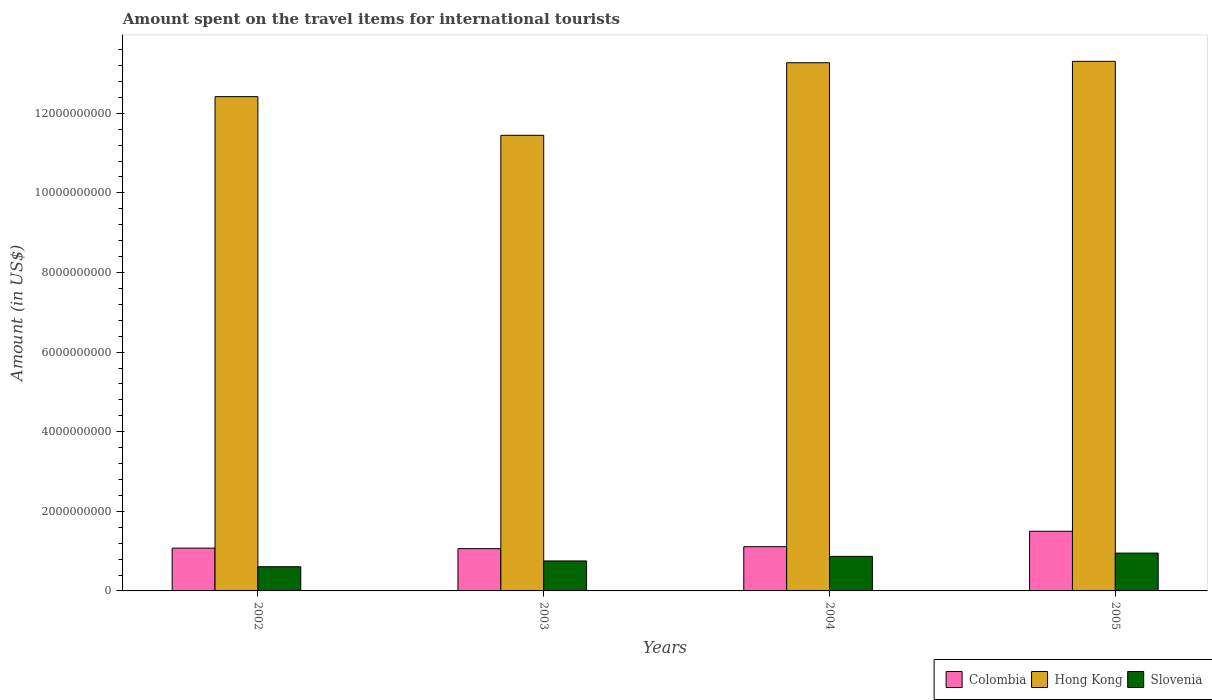How many different coloured bars are there?
Provide a succinct answer. 3. Are the number of bars per tick equal to the number of legend labels?
Provide a succinct answer. Yes. What is the amount spent on the travel items for international tourists in Colombia in 2004?
Offer a very short reply. 1.11e+09. Across all years, what is the maximum amount spent on the travel items for international tourists in Hong Kong?
Offer a terse response. 1.33e+1. Across all years, what is the minimum amount spent on the travel items for international tourists in Hong Kong?
Your answer should be very brief. 1.14e+1. In which year was the amount spent on the travel items for international tourists in Slovenia maximum?
Offer a terse response. 2005. What is the total amount spent on the travel items for international tourists in Colombia in the graph?
Offer a very short reply. 4.75e+09. What is the difference between the amount spent on the travel items for international tourists in Slovenia in 2003 and that in 2005?
Offer a terse response. -1.97e+08. What is the difference between the amount spent on the travel items for international tourists in Hong Kong in 2005 and the amount spent on the travel items for international tourists in Colombia in 2002?
Your answer should be compact. 1.22e+1. What is the average amount spent on the travel items for international tourists in Colombia per year?
Make the answer very short. 1.19e+09. In the year 2005, what is the difference between the amount spent on the travel items for international tourists in Colombia and amount spent on the travel items for international tourists in Hong Kong?
Your answer should be very brief. -1.18e+1. In how many years, is the amount spent on the travel items for international tourists in Hong Kong greater than 10400000000 US$?
Offer a terse response. 4. What is the ratio of the amount spent on the travel items for international tourists in Colombia in 2002 to that in 2003?
Keep it short and to the point. 1.01. Is the amount spent on the travel items for international tourists in Hong Kong in 2002 less than that in 2005?
Keep it short and to the point. Yes. Is the difference between the amount spent on the travel items for international tourists in Colombia in 2003 and 2005 greater than the difference between the amount spent on the travel items for international tourists in Hong Kong in 2003 and 2005?
Give a very brief answer. Yes. What is the difference between the highest and the second highest amount spent on the travel items for international tourists in Colombia?
Your response must be concise. 3.88e+08. What is the difference between the highest and the lowest amount spent on the travel items for international tourists in Colombia?
Give a very brief answer. 4.37e+08. Is the sum of the amount spent on the travel items for international tourists in Colombia in 2003 and 2004 greater than the maximum amount spent on the travel items for international tourists in Slovenia across all years?
Offer a very short reply. Yes. What does the 2nd bar from the left in 2003 represents?
Make the answer very short. Hong Kong. What does the 2nd bar from the right in 2005 represents?
Ensure brevity in your answer.  Hong Kong. Is it the case that in every year, the sum of the amount spent on the travel items for international tourists in Hong Kong and amount spent on the travel items for international tourists in Slovenia is greater than the amount spent on the travel items for international tourists in Colombia?
Keep it short and to the point. Yes. How many years are there in the graph?
Offer a terse response. 4. Are the values on the major ticks of Y-axis written in scientific E-notation?
Your response must be concise. No. Does the graph contain any zero values?
Your answer should be compact. No. Where does the legend appear in the graph?
Offer a terse response. Bottom right. How many legend labels are there?
Offer a very short reply. 3. How are the legend labels stacked?
Your answer should be compact. Horizontal. What is the title of the graph?
Ensure brevity in your answer.  Amount spent on the travel items for international tourists. What is the label or title of the X-axis?
Ensure brevity in your answer.  Years. What is the label or title of the Y-axis?
Offer a terse response. Amount (in US$). What is the Amount (in US$) in Colombia in 2002?
Provide a short and direct response. 1.08e+09. What is the Amount (in US$) in Hong Kong in 2002?
Ensure brevity in your answer.  1.24e+1. What is the Amount (in US$) of Slovenia in 2002?
Your answer should be very brief. 6.08e+08. What is the Amount (in US$) of Colombia in 2003?
Keep it short and to the point. 1.06e+09. What is the Amount (in US$) of Hong Kong in 2003?
Your answer should be very brief. 1.14e+1. What is the Amount (in US$) of Slovenia in 2003?
Provide a succinct answer. 7.53e+08. What is the Amount (in US$) in Colombia in 2004?
Provide a succinct answer. 1.11e+09. What is the Amount (in US$) in Hong Kong in 2004?
Your answer should be very brief. 1.33e+1. What is the Amount (in US$) in Slovenia in 2004?
Your answer should be very brief. 8.68e+08. What is the Amount (in US$) of Colombia in 2005?
Your answer should be very brief. 1.50e+09. What is the Amount (in US$) of Hong Kong in 2005?
Your answer should be very brief. 1.33e+1. What is the Amount (in US$) in Slovenia in 2005?
Provide a short and direct response. 9.50e+08. Across all years, what is the maximum Amount (in US$) of Colombia?
Your answer should be very brief. 1.50e+09. Across all years, what is the maximum Amount (in US$) of Hong Kong?
Your answer should be compact. 1.33e+1. Across all years, what is the maximum Amount (in US$) in Slovenia?
Your response must be concise. 9.50e+08. Across all years, what is the minimum Amount (in US$) of Colombia?
Provide a short and direct response. 1.06e+09. Across all years, what is the minimum Amount (in US$) in Hong Kong?
Your answer should be compact. 1.14e+1. Across all years, what is the minimum Amount (in US$) of Slovenia?
Your answer should be compact. 6.08e+08. What is the total Amount (in US$) of Colombia in the graph?
Your response must be concise. 4.75e+09. What is the total Amount (in US$) in Hong Kong in the graph?
Ensure brevity in your answer.  5.04e+1. What is the total Amount (in US$) in Slovenia in the graph?
Offer a terse response. 3.18e+09. What is the difference between the Amount (in US$) of Colombia in 2002 and that in 2003?
Your response must be concise. 1.30e+07. What is the difference between the Amount (in US$) in Hong Kong in 2002 and that in 2003?
Provide a short and direct response. 9.71e+08. What is the difference between the Amount (in US$) in Slovenia in 2002 and that in 2003?
Make the answer very short. -1.45e+08. What is the difference between the Amount (in US$) in Colombia in 2002 and that in 2004?
Your answer should be very brief. -3.60e+07. What is the difference between the Amount (in US$) of Hong Kong in 2002 and that in 2004?
Give a very brief answer. -8.52e+08. What is the difference between the Amount (in US$) in Slovenia in 2002 and that in 2004?
Your response must be concise. -2.60e+08. What is the difference between the Amount (in US$) of Colombia in 2002 and that in 2005?
Provide a succinct answer. -4.24e+08. What is the difference between the Amount (in US$) in Hong Kong in 2002 and that in 2005?
Offer a terse response. -8.87e+08. What is the difference between the Amount (in US$) in Slovenia in 2002 and that in 2005?
Your answer should be compact. -3.42e+08. What is the difference between the Amount (in US$) in Colombia in 2003 and that in 2004?
Ensure brevity in your answer.  -4.90e+07. What is the difference between the Amount (in US$) in Hong Kong in 2003 and that in 2004?
Your answer should be very brief. -1.82e+09. What is the difference between the Amount (in US$) of Slovenia in 2003 and that in 2004?
Keep it short and to the point. -1.15e+08. What is the difference between the Amount (in US$) of Colombia in 2003 and that in 2005?
Offer a very short reply. -4.37e+08. What is the difference between the Amount (in US$) of Hong Kong in 2003 and that in 2005?
Offer a terse response. -1.86e+09. What is the difference between the Amount (in US$) of Slovenia in 2003 and that in 2005?
Your response must be concise. -1.97e+08. What is the difference between the Amount (in US$) of Colombia in 2004 and that in 2005?
Provide a short and direct response. -3.88e+08. What is the difference between the Amount (in US$) of Hong Kong in 2004 and that in 2005?
Provide a succinct answer. -3.50e+07. What is the difference between the Amount (in US$) in Slovenia in 2004 and that in 2005?
Your answer should be compact. -8.20e+07. What is the difference between the Amount (in US$) in Colombia in 2002 and the Amount (in US$) in Hong Kong in 2003?
Provide a short and direct response. -1.04e+1. What is the difference between the Amount (in US$) of Colombia in 2002 and the Amount (in US$) of Slovenia in 2003?
Offer a terse response. 3.22e+08. What is the difference between the Amount (in US$) in Hong Kong in 2002 and the Amount (in US$) in Slovenia in 2003?
Your answer should be compact. 1.17e+1. What is the difference between the Amount (in US$) in Colombia in 2002 and the Amount (in US$) in Hong Kong in 2004?
Your response must be concise. -1.22e+1. What is the difference between the Amount (in US$) of Colombia in 2002 and the Amount (in US$) of Slovenia in 2004?
Make the answer very short. 2.07e+08. What is the difference between the Amount (in US$) in Hong Kong in 2002 and the Amount (in US$) in Slovenia in 2004?
Give a very brief answer. 1.16e+1. What is the difference between the Amount (in US$) of Colombia in 2002 and the Amount (in US$) of Hong Kong in 2005?
Offer a very short reply. -1.22e+1. What is the difference between the Amount (in US$) in Colombia in 2002 and the Amount (in US$) in Slovenia in 2005?
Ensure brevity in your answer.  1.25e+08. What is the difference between the Amount (in US$) in Hong Kong in 2002 and the Amount (in US$) in Slovenia in 2005?
Provide a short and direct response. 1.15e+1. What is the difference between the Amount (in US$) of Colombia in 2003 and the Amount (in US$) of Hong Kong in 2004?
Make the answer very short. -1.22e+1. What is the difference between the Amount (in US$) in Colombia in 2003 and the Amount (in US$) in Slovenia in 2004?
Ensure brevity in your answer.  1.94e+08. What is the difference between the Amount (in US$) in Hong Kong in 2003 and the Amount (in US$) in Slovenia in 2004?
Your response must be concise. 1.06e+1. What is the difference between the Amount (in US$) in Colombia in 2003 and the Amount (in US$) in Hong Kong in 2005?
Give a very brief answer. -1.22e+1. What is the difference between the Amount (in US$) of Colombia in 2003 and the Amount (in US$) of Slovenia in 2005?
Provide a succinct answer. 1.12e+08. What is the difference between the Amount (in US$) in Hong Kong in 2003 and the Amount (in US$) in Slovenia in 2005?
Give a very brief answer. 1.05e+1. What is the difference between the Amount (in US$) of Colombia in 2004 and the Amount (in US$) of Hong Kong in 2005?
Offer a very short reply. -1.22e+1. What is the difference between the Amount (in US$) in Colombia in 2004 and the Amount (in US$) in Slovenia in 2005?
Your answer should be compact. 1.61e+08. What is the difference between the Amount (in US$) of Hong Kong in 2004 and the Amount (in US$) of Slovenia in 2005?
Provide a succinct answer. 1.23e+1. What is the average Amount (in US$) in Colombia per year?
Ensure brevity in your answer.  1.19e+09. What is the average Amount (in US$) of Hong Kong per year?
Make the answer very short. 1.26e+1. What is the average Amount (in US$) in Slovenia per year?
Provide a short and direct response. 7.95e+08. In the year 2002, what is the difference between the Amount (in US$) of Colombia and Amount (in US$) of Hong Kong?
Ensure brevity in your answer.  -1.13e+1. In the year 2002, what is the difference between the Amount (in US$) in Colombia and Amount (in US$) in Slovenia?
Your response must be concise. 4.67e+08. In the year 2002, what is the difference between the Amount (in US$) in Hong Kong and Amount (in US$) in Slovenia?
Offer a terse response. 1.18e+1. In the year 2003, what is the difference between the Amount (in US$) of Colombia and Amount (in US$) of Hong Kong?
Give a very brief answer. -1.04e+1. In the year 2003, what is the difference between the Amount (in US$) of Colombia and Amount (in US$) of Slovenia?
Make the answer very short. 3.09e+08. In the year 2003, what is the difference between the Amount (in US$) in Hong Kong and Amount (in US$) in Slovenia?
Offer a terse response. 1.07e+1. In the year 2004, what is the difference between the Amount (in US$) in Colombia and Amount (in US$) in Hong Kong?
Your response must be concise. -1.22e+1. In the year 2004, what is the difference between the Amount (in US$) in Colombia and Amount (in US$) in Slovenia?
Provide a succinct answer. 2.43e+08. In the year 2004, what is the difference between the Amount (in US$) in Hong Kong and Amount (in US$) in Slovenia?
Provide a short and direct response. 1.24e+1. In the year 2005, what is the difference between the Amount (in US$) of Colombia and Amount (in US$) of Hong Kong?
Offer a terse response. -1.18e+1. In the year 2005, what is the difference between the Amount (in US$) in Colombia and Amount (in US$) in Slovenia?
Ensure brevity in your answer.  5.49e+08. In the year 2005, what is the difference between the Amount (in US$) of Hong Kong and Amount (in US$) of Slovenia?
Your answer should be compact. 1.24e+1. What is the ratio of the Amount (in US$) of Colombia in 2002 to that in 2003?
Give a very brief answer. 1.01. What is the ratio of the Amount (in US$) of Hong Kong in 2002 to that in 2003?
Give a very brief answer. 1.08. What is the ratio of the Amount (in US$) in Slovenia in 2002 to that in 2003?
Your answer should be very brief. 0.81. What is the ratio of the Amount (in US$) of Colombia in 2002 to that in 2004?
Ensure brevity in your answer.  0.97. What is the ratio of the Amount (in US$) of Hong Kong in 2002 to that in 2004?
Give a very brief answer. 0.94. What is the ratio of the Amount (in US$) of Slovenia in 2002 to that in 2004?
Your answer should be compact. 0.7. What is the ratio of the Amount (in US$) of Colombia in 2002 to that in 2005?
Make the answer very short. 0.72. What is the ratio of the Amount (in US$) in Slovenia in 2002 to that in 2005?
Your answer should be compact. 0.64. What is the ratio of the Amount (in US$) in Colombia in 2003 to that in 2004?
Ensure brevity in your answer.  0.96. What is the ratio of the Amount (in US$) in Hong Kong in 2003 to that in 2004?
Your response must be concise. 0.86. What is the ratio of the Amount (in US$) in Slovenia in 2003 to that in 2004?
Give a very brief answer. 0.87. What is the ratio of the Amount (in US$) of Colombia in 2003 to that in 2005?
Provide a succinct answer. 0.71. What is the ratio of the Amount (in US$) of Hong Kong in 2003 to that in 2005?
Your answer should be compact. 0.86. What is the ratio of the Amount (in US$) in Slovenia in 2003 to that in 2005?
Your answer should be compact. 0.79. What is the ratio of the Amount (in US$) in Colombia in 2004 to that in 2005?
Your response must be concise. 0.74. What is the ratio of the Amount (in US$) of Hong Kong in 2004 to that in 2005?
Provide a succinct answer. 1. What is the ratio of the Amount (in US$) in Slovenia in 2004 to that in 2005?
Offer a very short reply. 0.91. What is the difference between the highest and the second highest Amount (in US$) of Colombia?
Your answer should be very brief. 3.88e+08. What is the difference between the highest and the second highest Amount (in US$) in Hong Kong?
Offer a very short reply. 3.50e+07. What is the difference between the highest and the second highest Amount (in US$) of Slovenia?
Keep it short and to the point. 8.20e+07. What is the difference between the highest and the lowest Amount (in US$) in Colombia?
Offer a very short reply. 4.37e+08. What is the difference between the highest and the lowest Amount (in US$) in Hong Kong?
Make the answer very short. 1.86e+09. What is the difference between the highest and the lowest Amount (in US$) of Slovenia?
Provide a short and direct response. 3.42e+08. 